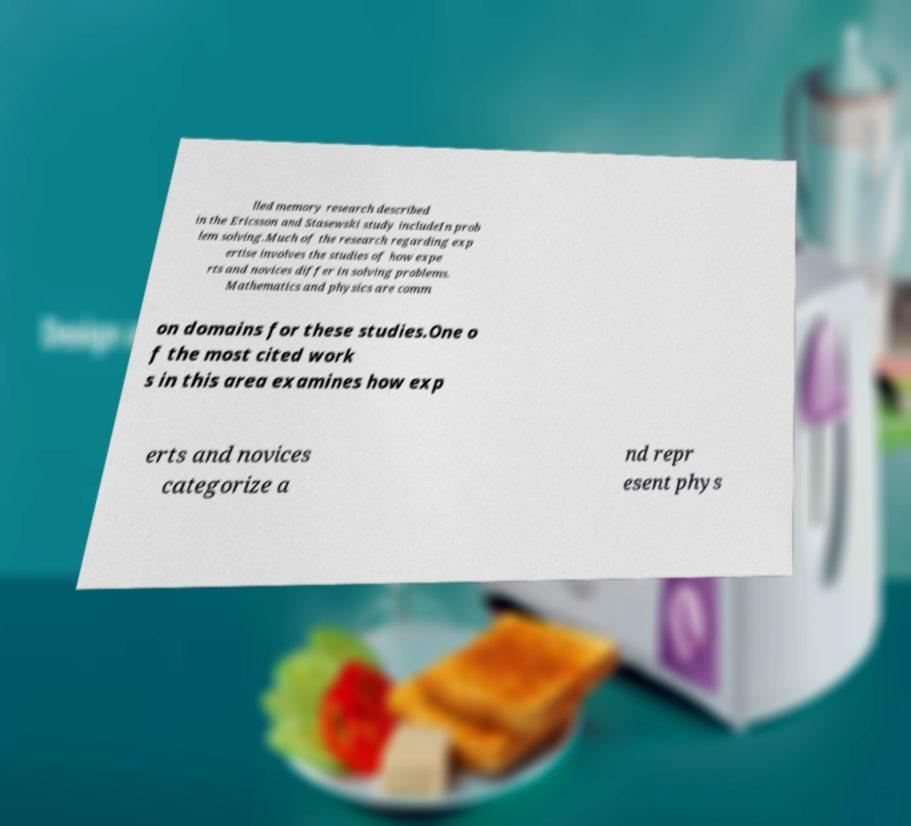For documentation purposes, I need the text within this image transcribed. Could you provide that? lled memory research described in the Ericsson and Stasewski study includeIn prob lem solving.Much of the research regarding exp ertise involves the studies of how expe rts and novices differ in solving problems. Mathematics and physics are comm on domains for these studies.One o f the most cited work s in this area examines how exp erts and novices categorize a nd repr esent phys 